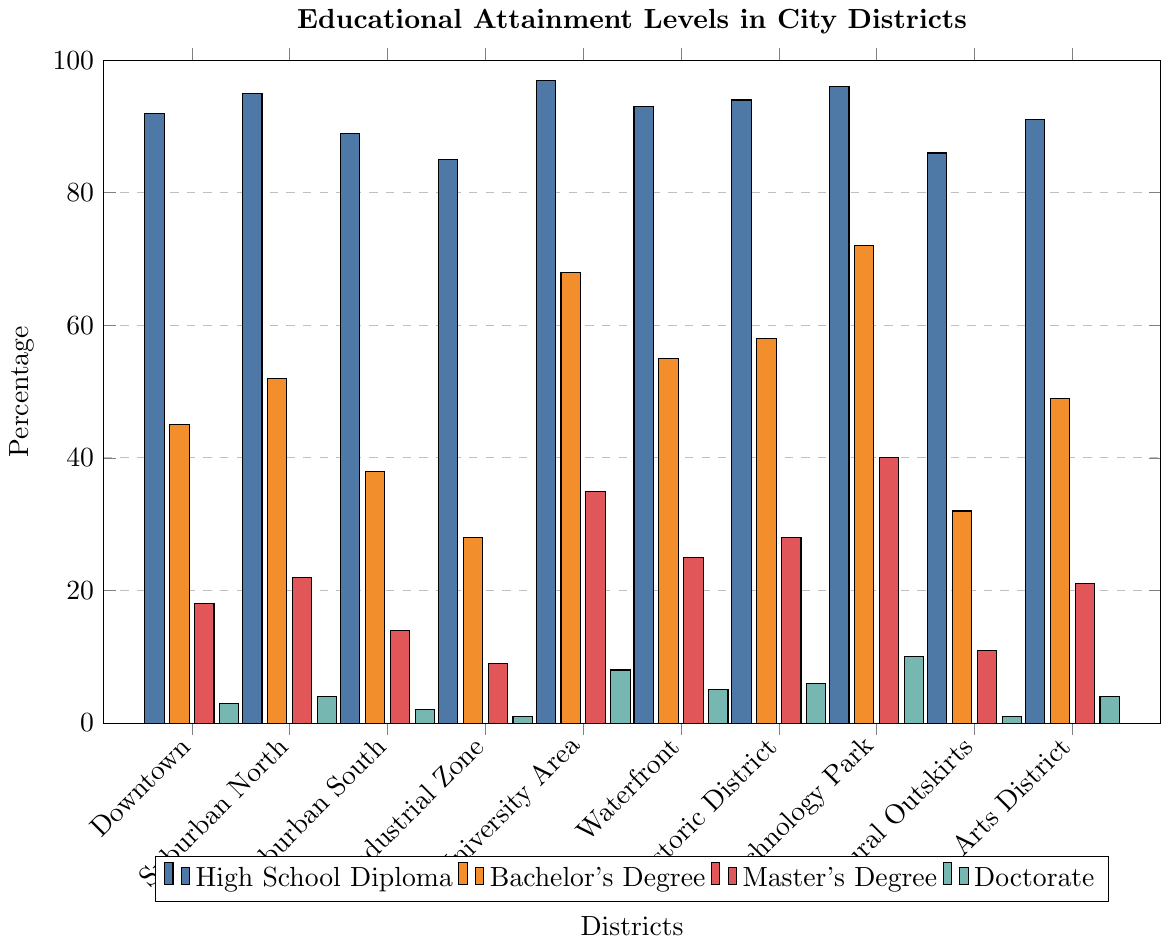Which district has the highest percentage of residents with doctoral degrees? The district with the highest bar for the doctoral degree category is the Technology Park with a value of 10%.
Answer: Technology Park Which district has the lowest percentage of residents with a high school diploma? The district with the shortest bar for the high school diploma category is the Industrial Zone at 85%.
Answer: Industrial Zone How much higher is the percentage of bachelor’s degrees in the Technology Park compared to the Industrial Zone? The percentage of bachelor’s degrees in Technology Park is 72%, while in the Industrial Zone, it is 28%. The difference is 72% - 28% = 44%.
Answer: 44% Which two districts have the closest percentages of residents with a master’s degree, and what are those percentages? Both the Suburban North and Arts District have master’s degree percentages of 22% and 21%, respectively. The difference between them is 1%.
Answer: Suburban North, Arts District (22%, 21%) What is the average percentage of residents with a bachelor’s degree among all the districts? Sum the percentages of bachelor’s degrees from all districts (45 + 52 + 38 + 28 + 68 + 55 + 58 + 72 + 32 + 49) = 497, then divide by the number of districts (10) to get 497 / 10 = 49.7%.
Answer: 49.7% In which district is the percentage of residents with master’s degrees more than double the percentage in the Industrial Zone? In the University Area, the percentage of master’s degrees is 35%, which is more than double the Industrial Zone's 9% (2 * 9% = 18%).
Answer: University Area Which district has a higher percentage of residents with a doctorate, Suburban South or Waterfront, and by how much? The Waterfront has a higher doctoral degree percentage (5%) compared to the Suburban South (2%). The difference is 5% - 2% = 3%.
Answer: Waterfront by 3% How do the educational attainment levels in the University Area compare to the Historic District for bachelor's degrees? The University Area has a higher bachelor’s degree percentage (68%) compared to the Historic District (58%).
Answer: University Area has 10% more What is the total percentage of doctoral degrees across all districts? Sum the percentages of doctoral degrees from all districts (3 + 4 + 2 + 1 + 8 + 5 + 6 + 10 + 1 + 4) = 44%.
Answer: 44% Which district has the lowest difference between the percentage of residents with a high school diploma and those with a bachelor's degree? The University Area has 97% with high school diplomas and 68% with bachelor’s degrees. The difference is 97% - 68% = 29%, which is the smallest difference observed.
Answer: University Area 